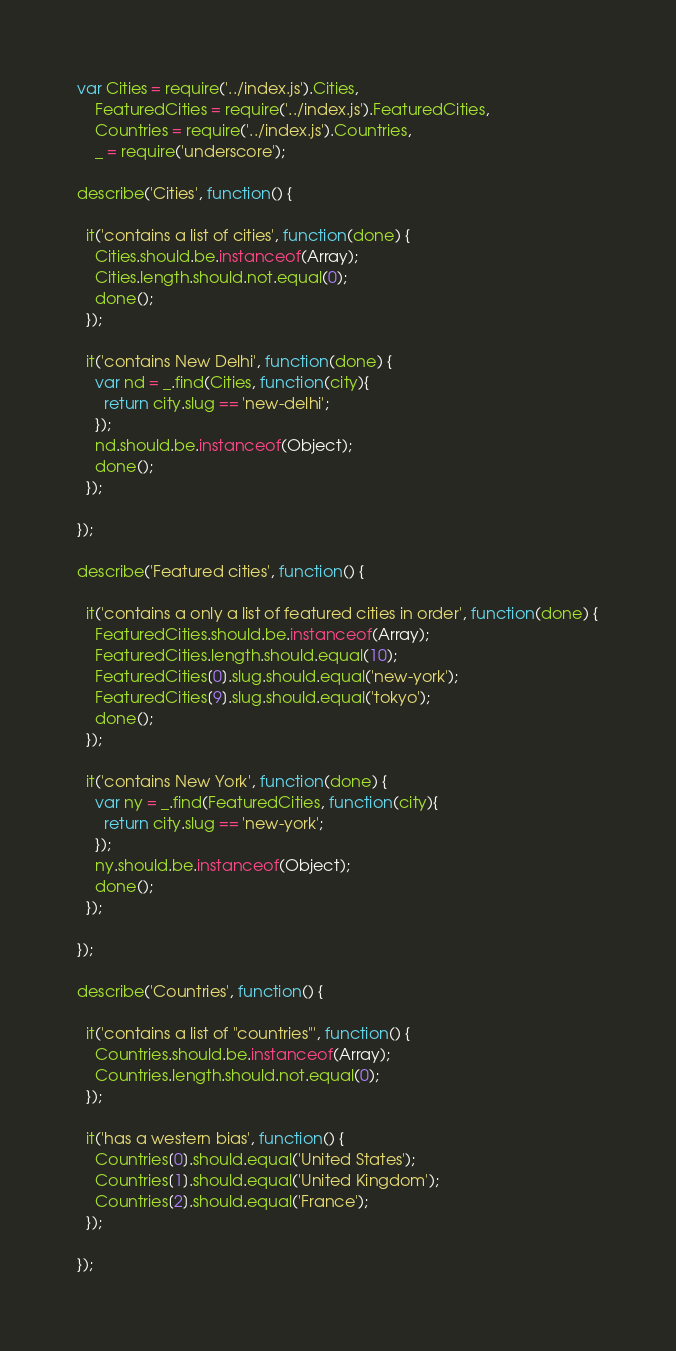<code> <loc_0><loc_0><loc_500><loc_500><_JavaScript_>var Cities = require('../index.js').Cities,
    FeaturedCities = require('../index.js').FeaturedCities,
    Countries = require('../index.js').Countries,
    _ = require('underscore');

describe('Cities', function() {

  it('contains a list of cities', function(done) {
    Cities.should.be.instanceof(Array);
    Cities.length.should.not.equal(0);
    done();
  });

  it('contains New Delhi', function(done) {
    var nd = _.find(Cities, function(city){
      return city.slug == 'new-delhi';
    });
    nd.should.be.instanceof(Object);
    done();
  });

});

describe('Featured cities', function() {

  it('contains a only a list of featured cities in order', function(done) {
    FeaturedCities.should.be.instanceof(Array);
    FeaturedCities.length.should.equal(10);
    FeaturedCities[0].slug.should.equal('new-york');
    FeaturedCities[9].slug.should.equal('tokyo');
    done();
  });

  it('contains New York', function(done) {
    var ny = _.find(FeaturedCities, function(city){
      return city.slug == 'new-york';
    });
    ny.should.be.instanceof(Object);
    done();
  });

});

describe('Countries', function() {

  it('contains a list of "countries"', function() {
    Countries.should.be.instanceof(Array);
    Countries.length.should.not.equal(0);
  });

  it('has a western bias', function() {
    Countries[0].should.equal('United States');
    Countries[1].should.equal('United Kingdom');
    Countries[2].should.equal('France');
  });

});</code> 